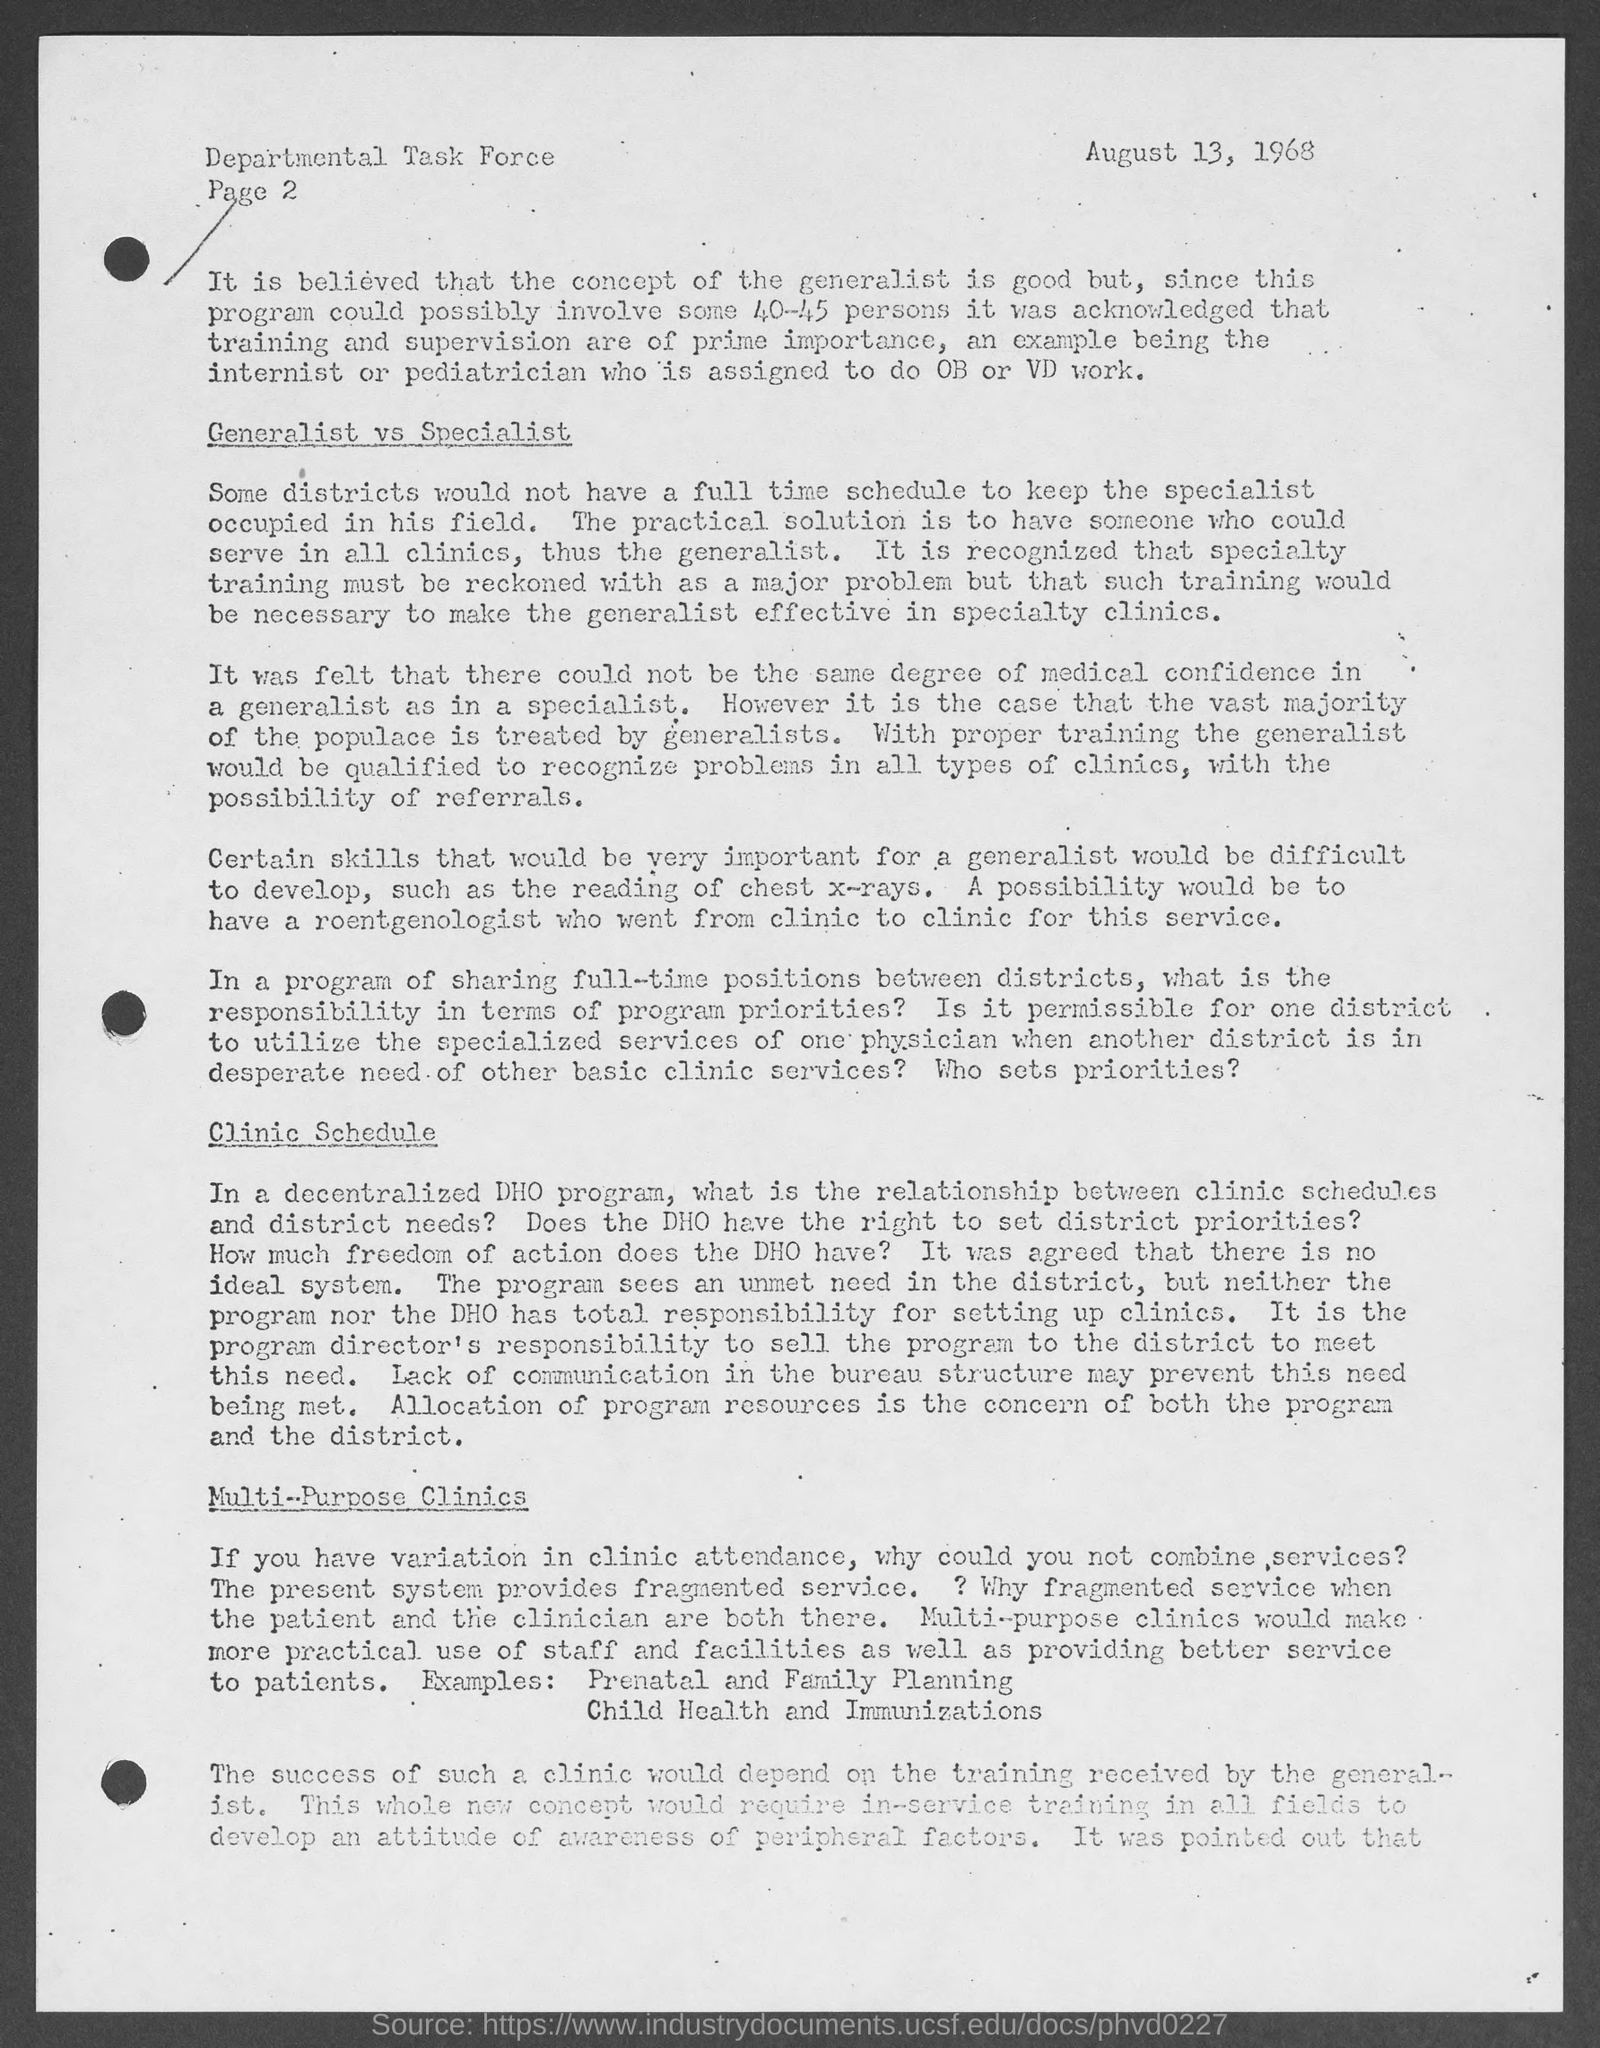List a handful of essential elements in this visual. The Departmental Task Force is mentioned in the header of the document. The page number mentioned in this document is Page 2. 